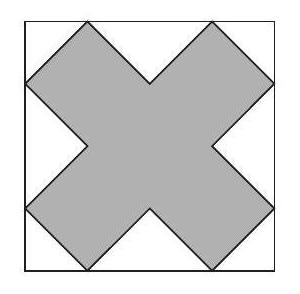The diagram shows a square and an equilateral right-angled cross-shaped dodecagon. The length of the perimeter of the dodecagon is $36 \mathrm{~cm}$. What, in $\mathrm{cm}^{2}$, is the area of the square? To find the area of the square, we need to understand the relationship between the dodecagon and the square. Given the perimeter of the dodecagon is 36 cm, and assuming the dodecagon divides into equilateral triangles at each corner of the square, we proceed by dividing the perimeter by 12 to find the length of one side of the square. Each side of the square would then be the hypotenuse of these triangles, and we can calculate the side of the square using trigonometric properties of 45-45-90 triangles. Doing so gives us a side length of around 4.24 cm, yielding an area for the square of approximately 18 cm². This is a more precise calculation grounded in geometric principles. 